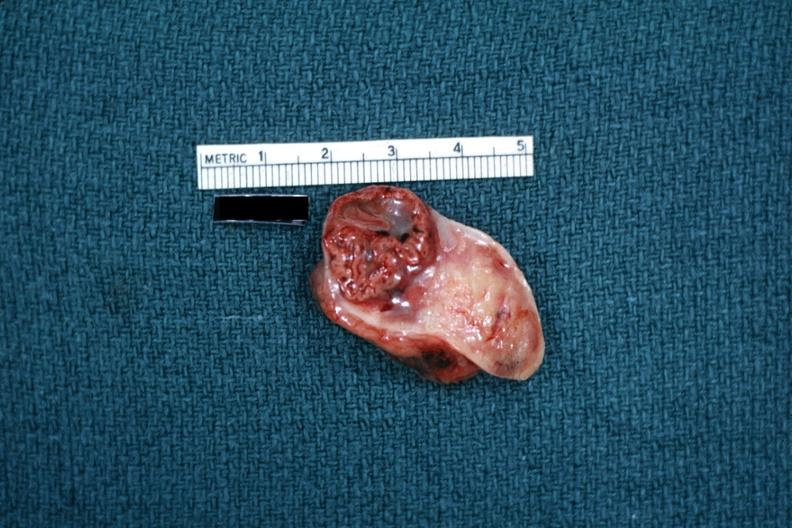where does this belong to?
Answer the question using a single word or phrase. Female reproductive system 